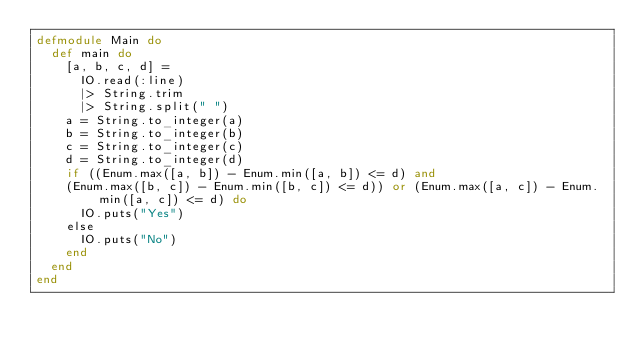<code> <loc_0><loc_0><loc_500><loc_500><_Elixir_>defmodule Main do
  def main do
    [a, b, c, d] =
      IO.read(:line)
      |> String.trim
      |> String.split(" ")
    a = String.to_integer(a)
    b = String.to_integer(b)
    c = String.to_integer(c)
    d = String.to_integer(d)
    if ((Enum.max([a, b]) - Enum.min([a, b]) <= d) and
    (Enum.max([b, c]) - Enum.min([b, c]) <= d)) or (Enum.max([a, c]) - Enum.min([a, c]) <= d) do
    	IO.puts("Yes")
    else
    	IO.puts("No")
    end
  end
end
</code> 